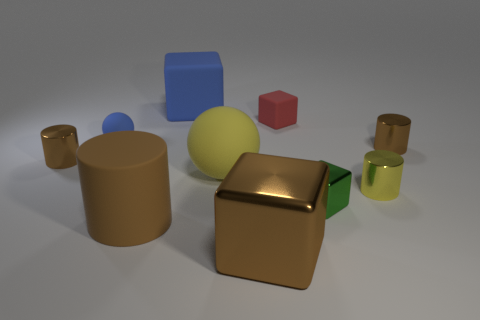Subtract all small red matte blocks. How many blocks are left? 3 Subtract 2 blocks. How many blocks are left? 2 Subtract all blue cubes. How many cubes are left? 3 Add 2 large green shiny cubes. How many large green shiny cubes exist? 2 Subtract 3 brown cylinders. How many objects are left? 7 Subtract all blocks. How many objects are left? 6 Subtract all blue spheres. Subtract all gray cylinders. How many spheres are left? 1 Subtract all brown balls. How many yellow cylinders are left? 1 Subtract all yellow rubber things. Subtract all large blue matte things. How many objects are left? 8 Add 2 tiny yellow shiny things. How many tiny yellow shiny things are left? 3 